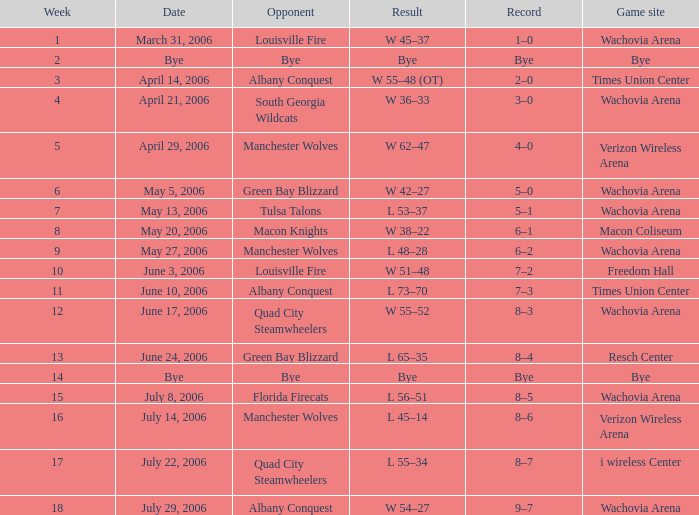Parse the full table. {'header': ['Week', 'Date', 'Opponent', 'Result', 'Record', 'Game site'], 'rows': [['1', 'March 31, 2006', 'Louisville Fire', 'W 45–37', '1–0', 'Wachovia Arena'], ['2', 'Bye', 'Bye', 'Bye', 'Bye', 'Bye'], ['3', 'April 14, 2006', 'Albany Conquest', 'W 55–48 (OT)', '2–0', 'Times Union Center'], ['4', 'April 21, 2006', 'South Georgia Wildcats', 'W 36–33', '3–0', 'Wachovia Arena'], ['5', 'April 29, 2006', 'Manchester Wolves', 'W 62–47', '4–0', 'Verizon Wireless Arena'], ['6', 'May 5, 2006', 'Green Bay Blizzard', 'W 42–27', '5–0', 'Wachovia Arena'], ['7', 'May 13, 2006', 'Tulsa Talons', 'L 53–37', '5–1', 'Wachovia Arena'], ['8', 'May 20, 2006', 'Macon Knights', 'W 38–22', '6–1', 'Macon Coliseum'], ['9', 'May 27, 2006', 'Manchester Wolves', 'L 48–28', '6–2', 'Wachovia Arena'], ['10', 'June 3, 2006', 'Louisville Fire', 'W 51–48', '7–2', 'Freedom Hall'], ['11', 'June 10, 2006', 'Albany Conquest', 'L 73–70', '7–3', 'Times Union Center'], ['12', 'June 17, 2006', 'Quad City Steamwheelers', 'W 55–52', '8–3', 'Wachovia Arena'], ['13', 'June 24, 2006', 'Green Bay Blizzard', 'L 65–35', '8–4', 'Resch Center'], ['14', 'Bye', 'Bye', 'Bye', 'Bye', 'Bye'], ['15', 'July 8, 2006', 'Florida Firecats', 'L 56–51', '8–5', 'Wachovia Arena'], ['16', 'July 14, 2006', 'Manchester Wolves', 'L 45–14', '8–6', 'Verizon Wireless Arena'], ['17', 'July 22, 2006', 'Quad City Steamwheelers', 'L 55–34', '8–7', 'i wireless Center'], ['18', 'July 29, 2006', 'Albany Conquest', 'W 54–27', '9–7', 'Wachovia Arena']]} What is the Game site week 1? Wachovia Arena. 